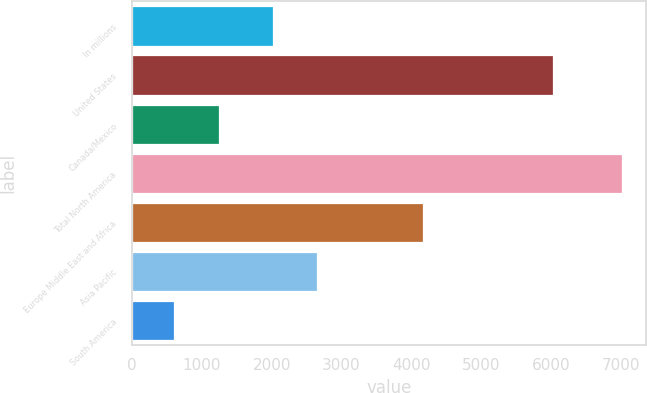Convert chart. <chart><loc_0><loc_0><loc_500><loc_500><bar_chart><fcel>In millions<fcel>United States<fcel>Canada/Mexico<fcel>Total North America<fcel>Europe Middle East and Africa<fcel>Asia Pacific<fcel>South America<nl><fcel>2013<fcel>6030<fcel>1243.9<fcel>7003<fcel>4162<fcel>2652.9<fcel>604<nl></chart> 